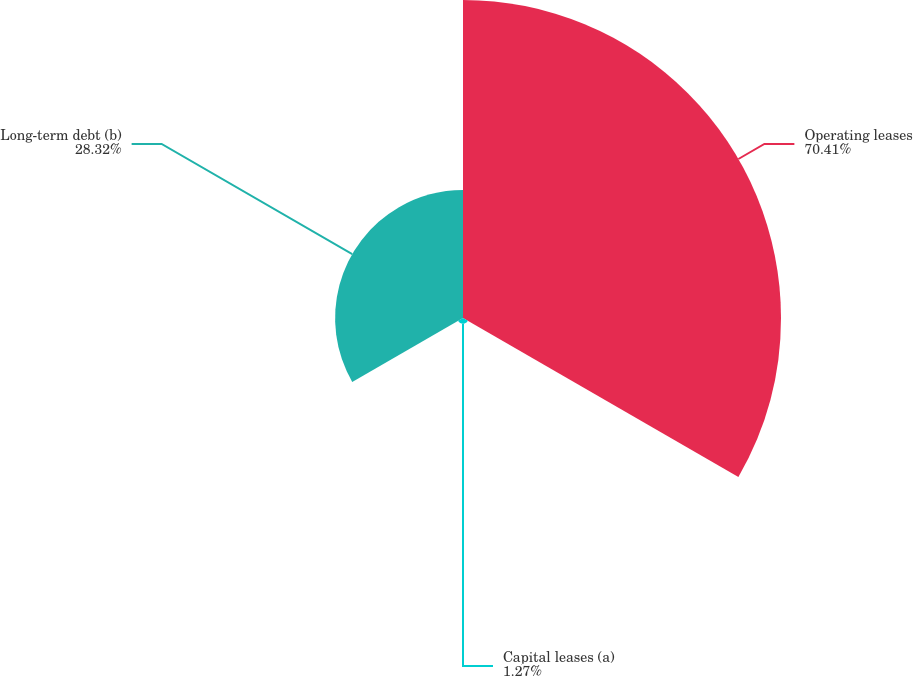Convert chart to OTSL. <chart><loc_0><loc_0><loc_500><loc_500><pie_chart><fcel>Operating leases<fcel>Capital leases (a)<fcel>Long-term debt (b)<nl><fcel>70.41%<fcel>1.27%<fcel>28.32%<nl></chart> 